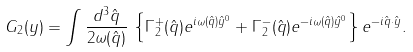Convert formula to latex. <formula><loc_0><loc_0><loc_500><loc_500>G _ { 2 } ( y ) = \int \frac { d ^ { 3 } \hat { q } } { 2 \omega ( \hat { q } ) } \, \left \{ \Gamma _ { 2 } ^ { + } ( \hat { q } ) e ^ { i \omega ( \hat { q } ) \hat { y } ^ { 0 } } + \Gamma _ { 2 } ^ { - } ( \hat { q } ) e ^ { - i \omega ( \hat { q } ) \hat { y } ^ { 0 } } \right \} e ^ { - i \hat { q } \cdot \hat { y } } .</formula> 